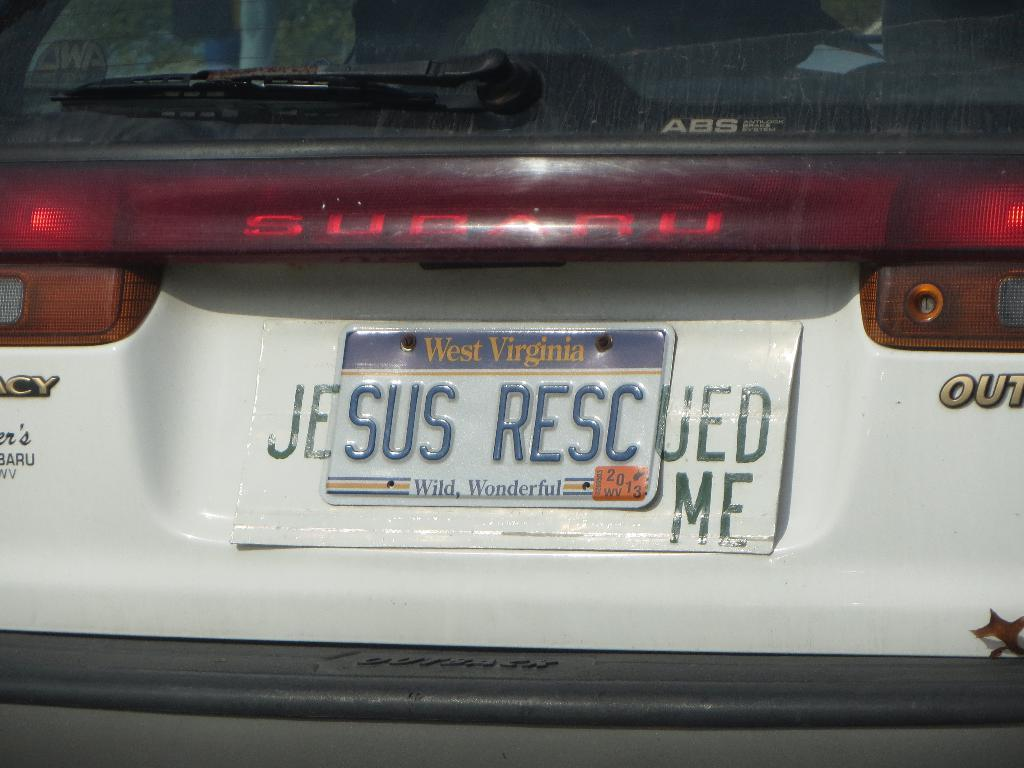<image>
Describe the image concisely. A license plate on a car says jesus resc. 